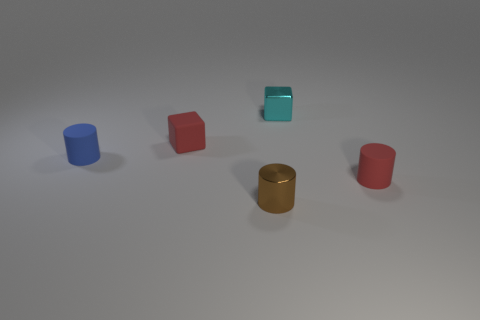Add 4 cubes. How many objects exist? 9 Subtract all cylinders. How many objects are left? 2 Subtract all metallic objects. Subtract all red rubber cylinders. How many objects are left? 2 Add 4 matte cubes. How many matte cubes are left? 5 Add 5 purple matte balls. How many purple matte balls exist? 5 Subtract 0 brown spheres. How many objects are left? 5 